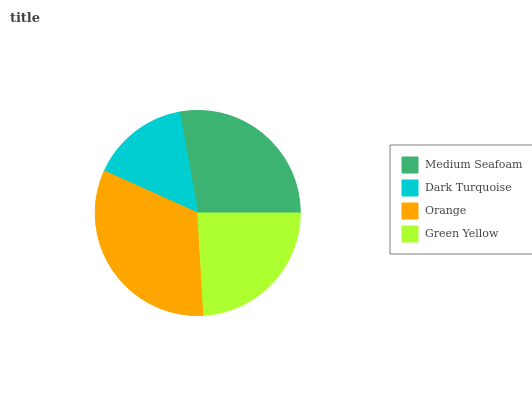Is Dark Turquoise the minimum?
Answer yes or no. Yes. Is Orange the maximum?
Answer yes or no. Yes. Is Orange the minimum?
Answer yes or no. No. Is Dark Turquoise the maximum?
Answer yes or no. No. Is Orange greater than Dark Turquoise?
Answer yes or no. Yes. Is Dark Turquoise less than Orange?
Answer yes or no. Yes. Is Dark Turquoise greater than Orange?
Answer yes or no. No. Is Orange less than Dark Turquoise?
Answer yes or no. No. Is Medium Seafoam the high median?
Answer yes or no. Yes. Is Green Yellow the low median?
Answer yes or no. Yes. Is Dark Turquoise the high median?
Answer yes or no. No. Is Orange the low median?
Answer yes or no. No. 